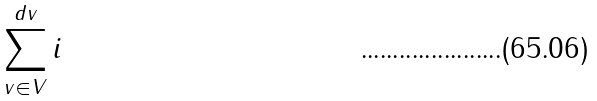<formula> <loc_0><loc_0><loc_500><loc_500>\sum _ { v \in V } ^ { d v } i</formula> 